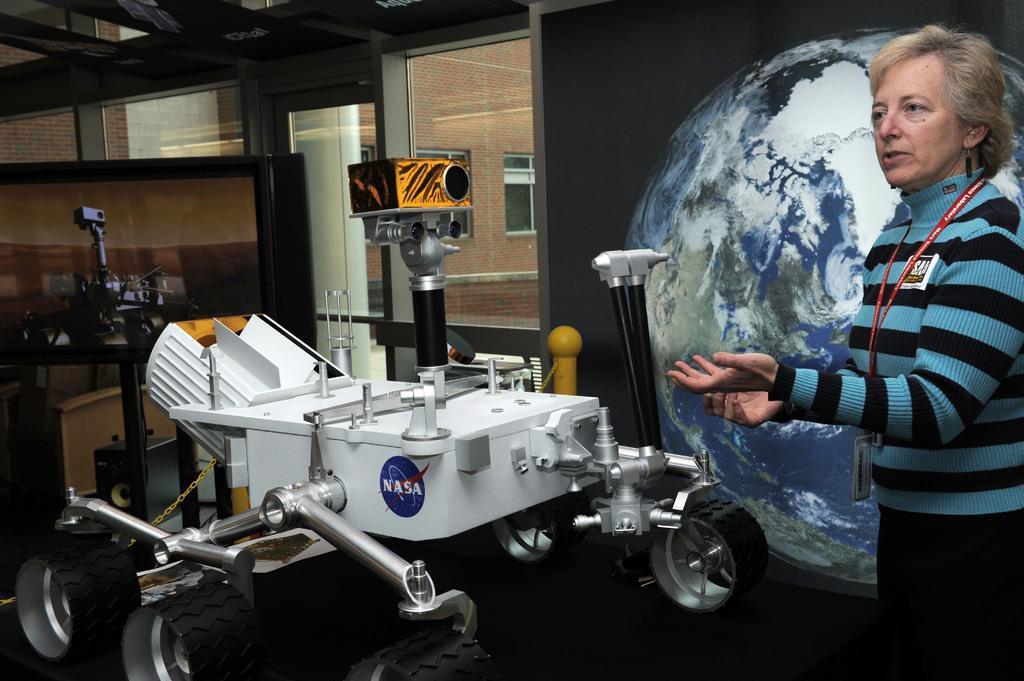Please provide a concise description of this image. In this picture we can see a woman standing on the path and in front of the woman there is a machine and on the machine it is written as "NASA". Behind the machine, there is a wall with a glass window. Through the window we can see a building. 